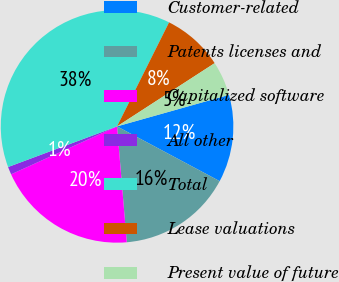Convert chart to OTSL. <chart><loc_0><loc_0><loc_500><loc_500><pie_chart><fcel>Customer-related<fcel>Patents licenses and<fcel>Capitalized software<fcel>All other<fcel>Total<fcel>Lease valuations<fcel>Present value of future<nl><fcel>12.17%<fcel>15.87%<fcel>19.57%<fcel>1.08%<fcel>38.06%<fcel>8.47%<fcel>4.78%<nl></chart> 